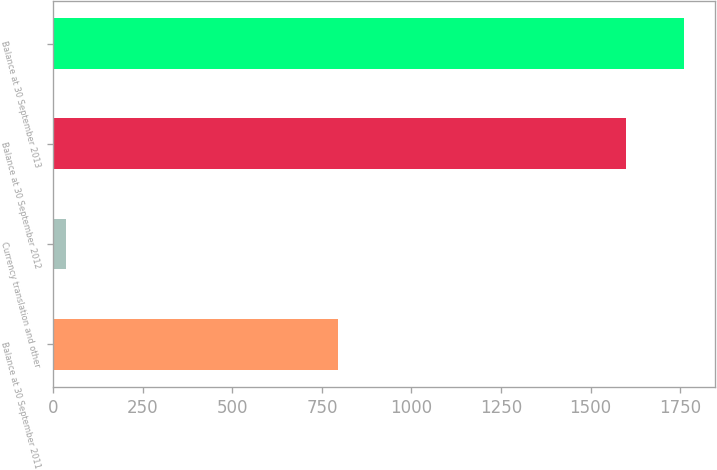<chart> <loc_0><loc_0><loc_500><loc_500><bar_chart><fcel>Balance at 30 September 2011<fcel>Currency translation and other<fcel>Balance at 30 September 2012<fcel>Balance at 30 September 2013<nl><fcel>796.2<fcel>36.8<fcel>1598.4<fcel>1760.1<nl></chart> 